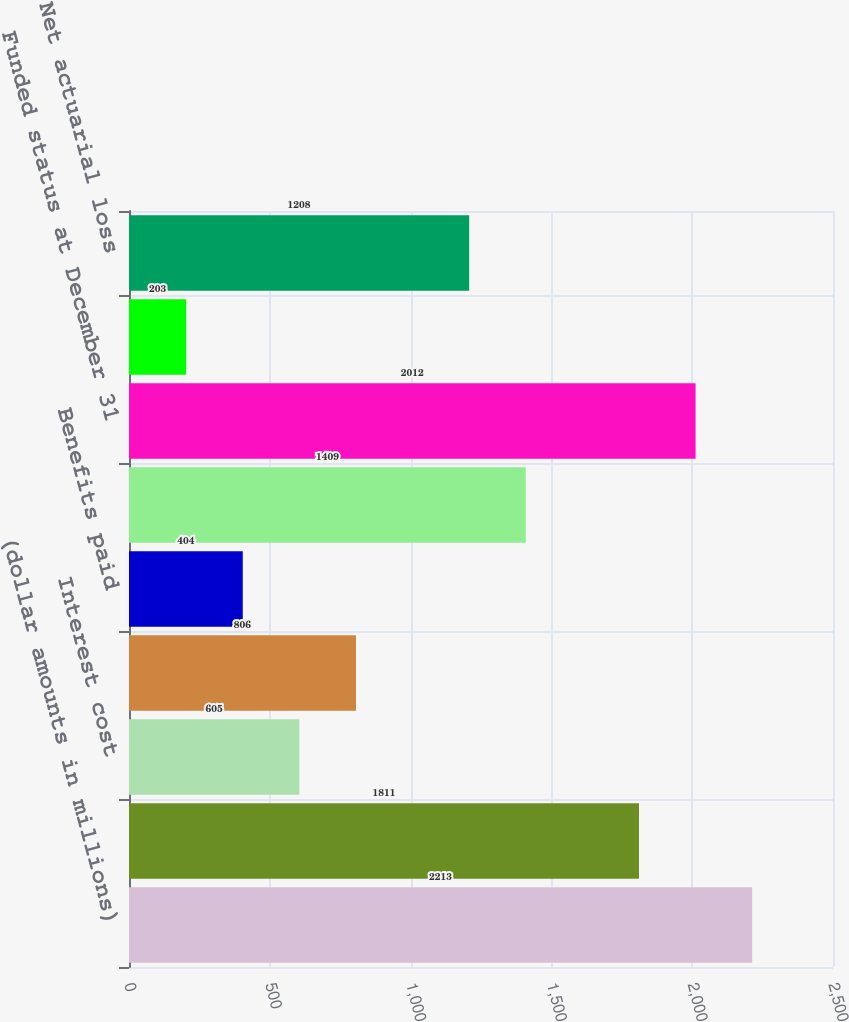<chart> <loc_0><loc_0><loc_500><loc_500><bar_chart><fcel>(dollar amounts in millions)<fcel>Projected benefit obligation<fcel>Interest cost<fcel>Actuarial (gain) loss<fcel>Benefits paid<fcel>Accumulated benefit obligation<fcel>Funded status at December 31<fcel>Discount rate<fcel>Net actuarial loss<nl><fcel>2213<fcel>1811<fcel>605<fcel>806<fcel>404<fcel>1409<fcel>2012<fcel>203<fcel>1208<nl></chart> 